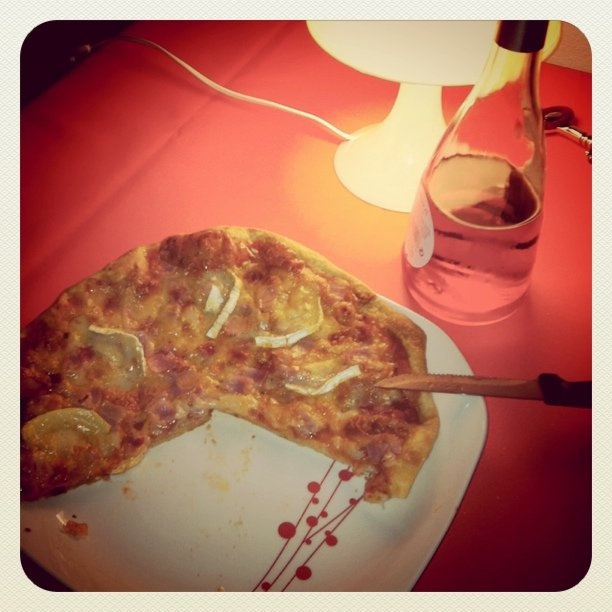Describe the objects in this image and their specific colors. I can see pizza in ivory, brown, maroon, and tan tones, bottle in ivory, salmon, tan, brown, and maroon tones, and knife in ivory, maroon, black, and brown tones in this image. 